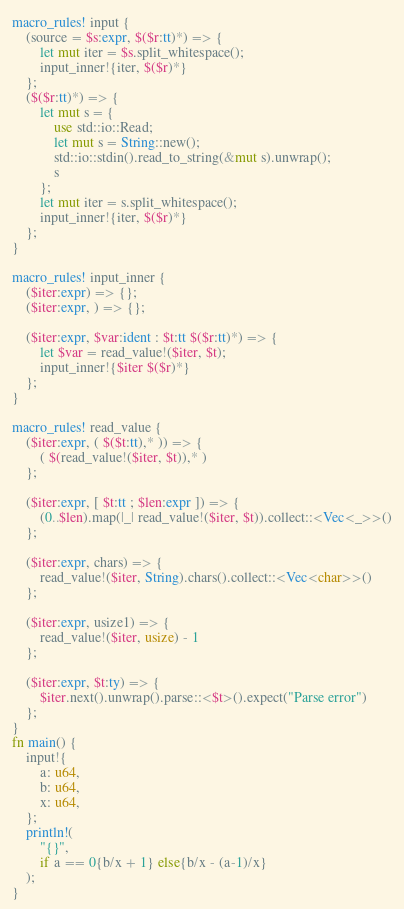<code> <loc_0><loc_0><loc_500><loc_500><_Rust_>macro_rules! input {
    (source = $s:expr, $($r:tt)*) => {
        let mut iter = $s.split_whitespace();
        input_inner!{iter, $($r)*}
    };
    ($($r:tt)*) => {
        let mut s = {
            use std::io::Read;
            let mut s = String::new();
            std::io::stdin().read_to_string(&mut s).unwrap();
            s
        };
        let mut iter = s.split_whitespace();
        input_inner!{iter, $($r)*}
    };
}

macro_rules! input_inner {
    ($iter:expr) => {};
    ($iter:expr, ) => {};

    ($iter:expr, $var:ident : $t:tt $($r:tt)*) => {
        let $var = read_value!($iter, $t);
        input_inner!{$iter $($r)*}
    };
}

macro_rules! read_value {
    ($iter:expr, ( $($t:tt),* )) => {
        ( $(read_value!($iter, $t)),* )
    };

    ($iter:expr, [ $t:tt ; $len:expr ]) => {
        (0..$len).map(|_| read_value!($iter, $t)).collect::<Vec<_>>()
    };

    ($iter:expr, chars) => {
        read_value!($iter, String).chars().collect::<Vec<char>>()
    };

    ($iter:expr, usize1) => {
        read_value!($iter, usize) - 1
    };

    ($iter:expr, $t:ty) => {
        $iter.next().unwrap().parse::<$t>().expect("Parse error")
    };
}
fn main() {
    input!{
        a: u64,
        b: u64,
        x: u64,
    };
    println!(
        "{}",
        if a == 0{b/x + 1} else{b/x - (a-1)/x}
    );
}
</code> 